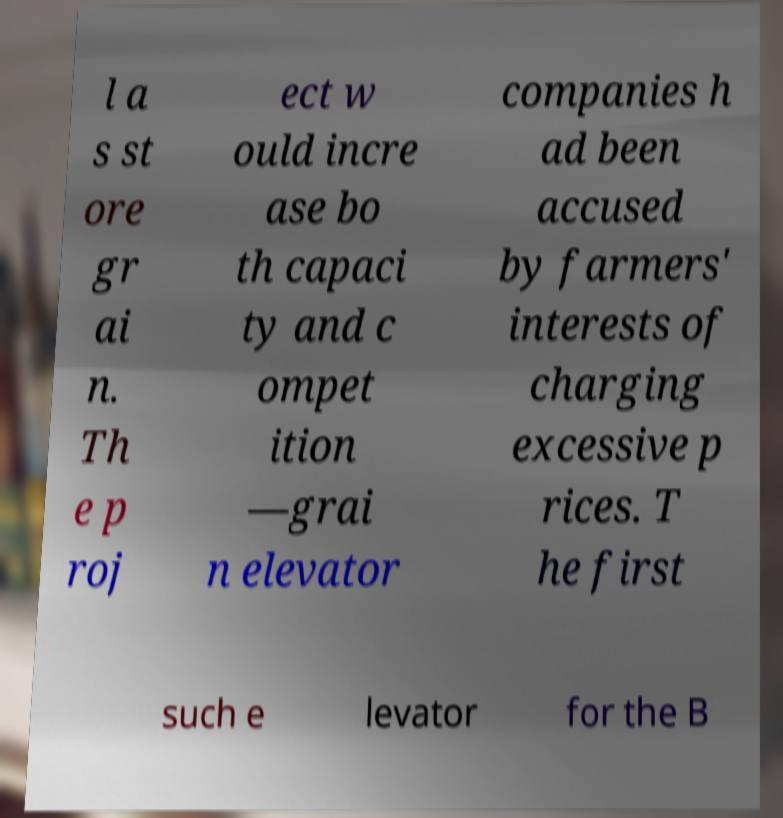Can you read and provide the text displayed in the image?This photo seems to have some interesting text. Can you extract and type it out for me? l a s st ore gr ai n. Th e p roj ect w ould incre ase bo th capaci ty and c ompet ition —grai n elevator companies h ad been accused by farmers' interests of charging excessive p rices. T he first such e levator for the B 